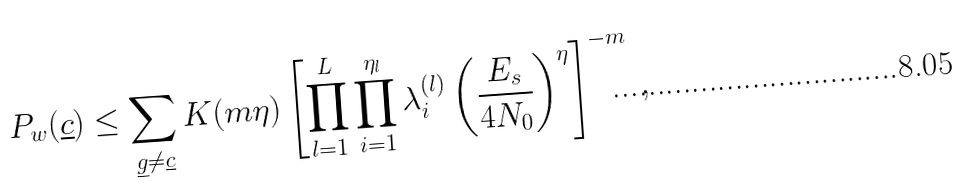Convert formula to latex. <formula><loc_0><loc_0><loc_500><loc_500>P _ { w } ( \underline { c } ) \leq \sum _ { \underline { g } \neq \underline { c } } K ( m \eta ) \left [ \prod _ { l = 1 } ^ { L } \prod _ { i = 1 } ^ { { \eta _ { l } } } \lambda _ { i } ^ { ( l ) } \left ( \frac { E _ { s } } { 4 N _ { 0 } } \right ) ^ { \eta } \right ] ^ { - m } \, ,</formula> 